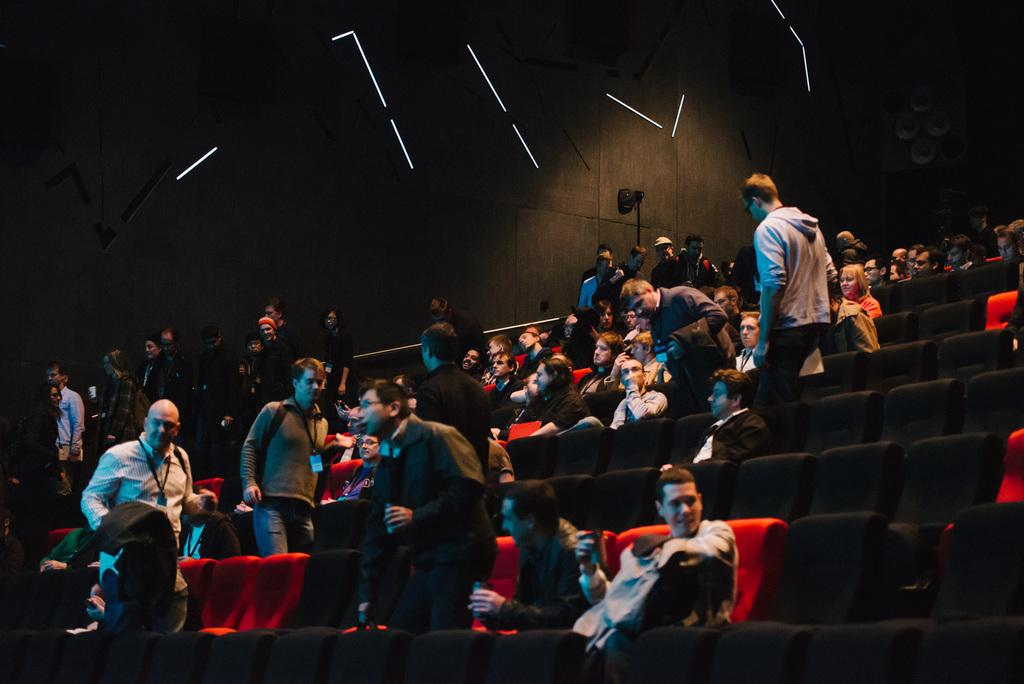How many people are in the image? There is a group of persons in the image. What are the people in the image doing? Some of the persons are sitting, while others are standing. Are there any available seats in the image? Yes, there are empty seats in the image. What can be seen in the background of the image? There are lights in the background of the image. What is the color of the object in the image? There is an object in the image that is black in color. What type of hearing aid is the person in the image using? There is no hearing aid visible in the image. What type of knife can be seen in the image? There is no knife present in the image. 